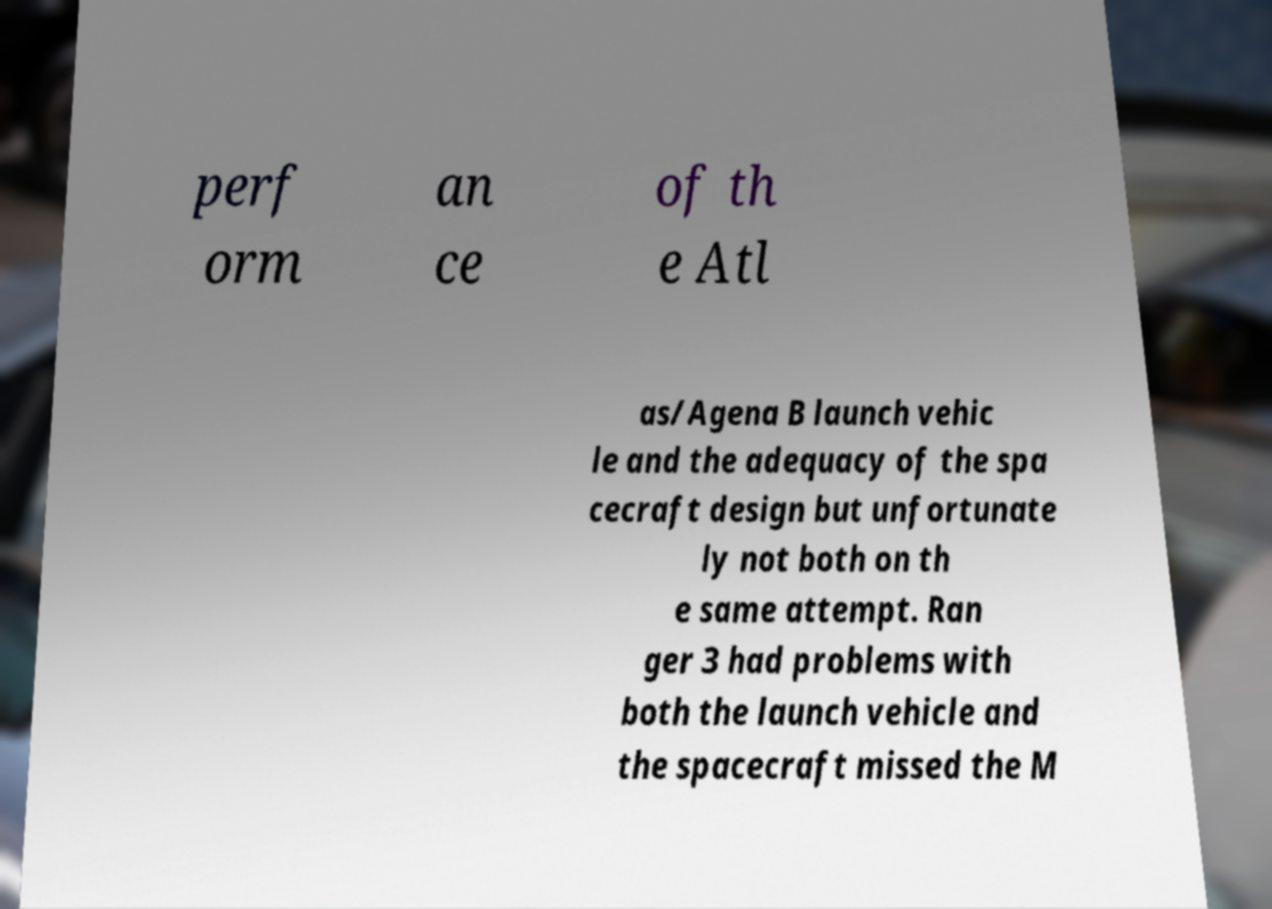Could you extract and type out the text from this image? perf orm an ce of th e Atl as/Agena B launch vehic le and the adequacy of the spa cecraft design but unfortunate ly not both on th e same attempt. Ran ger 3 had problems with both the launch vehicle and the spacecraft missed the M 